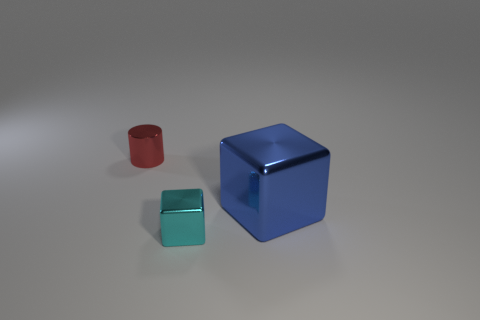Is there any other thing that is the same size as the blue block?
Provide a succinct answer. No. There is a small thing in front of the tiny shiny cylinder; what is it made of?
Ensure brevity in your answer.  Metal. Are there an equal number of red things that are in front of the large blue metallic cube and big blue matte cylinders?
Give a very brief answer. Yes. What is the color of the other big metal object that is the same shape as the cyan object?
Provide a short and direct response. Blue. Is the size of the red object the same as the blue object?
Your answer should be compact. No. Is the number of small metallic blocks behind the tiny cylinder the same as the number of shiny things to the left of the tiny shiny cube?
Ensure brevity in your answer.  No. Is there a matte cylinder?
Provide a succinct answer. No. The blue object that is the same shape as the small cyan metal thing is what size?
Offer a terse response. Large. What size is the thing to the left of the cyan metallic block?
Offer a terse response. Small. Are there more small cylinders behind the large blue metallic thing than big yellow spheres?
Ensure brevity in your answer.  Yes. 